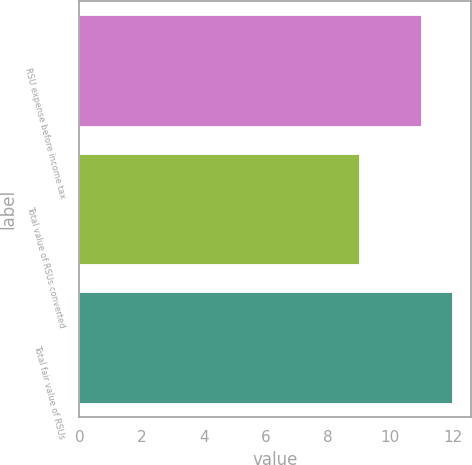Convert chart. <chart><loc_0><loc_0><loc_500><loc_500><bar_chart><fcel>RSU expense before income tax<fcel>Total value of RSUs converted<fcel>Total fair value of RSUs<nl><fcel>11<fcel>9<fcel>12<nl></chart> 